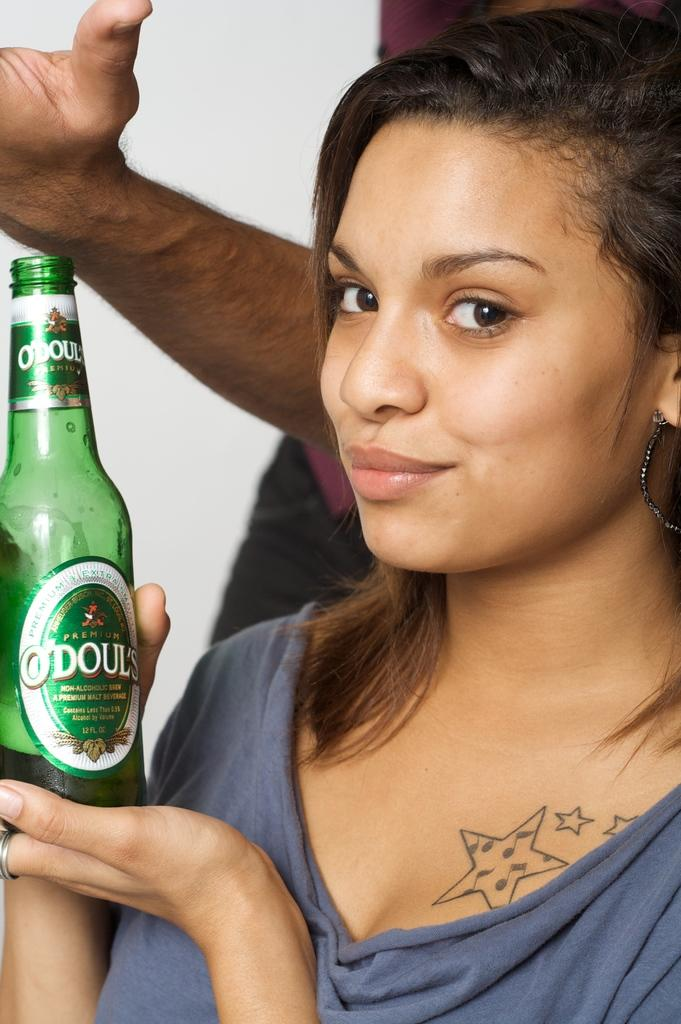What is the main subject of the image? The main subject of the image is a lady person. Can you describe what the lady person is wearing? The lady person is wearing a blue dress. What object is the lady person holding in the image? The lady person is holding a bottle. What type of pollution can be seen in the image? There is no pollution present in the image. What kind of plastic material is visible in the image? There is no plastic material visible in the image. 